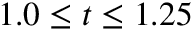<formula> <loc_0><loc_0><loc_500><loc_500>1 . 0 \leq t \leq 1 . 2 5</formula> 